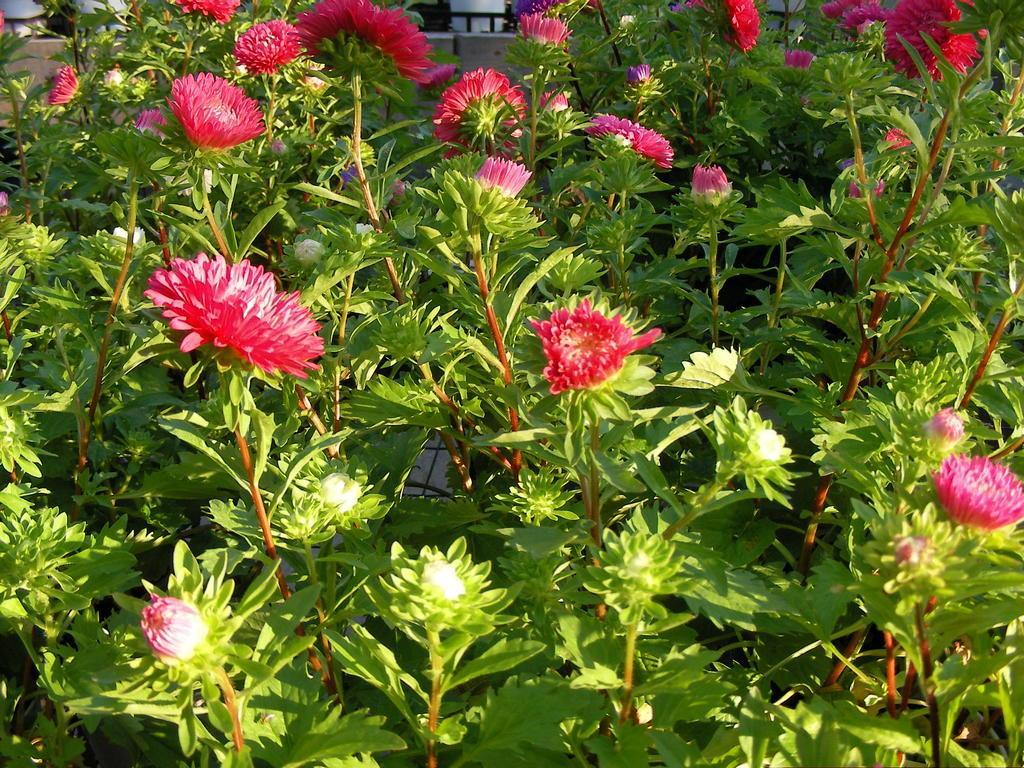In one or two sentences, can you explain what this image depicts? In this picture I can see few flowers to the plants and looks like a house in the back. 